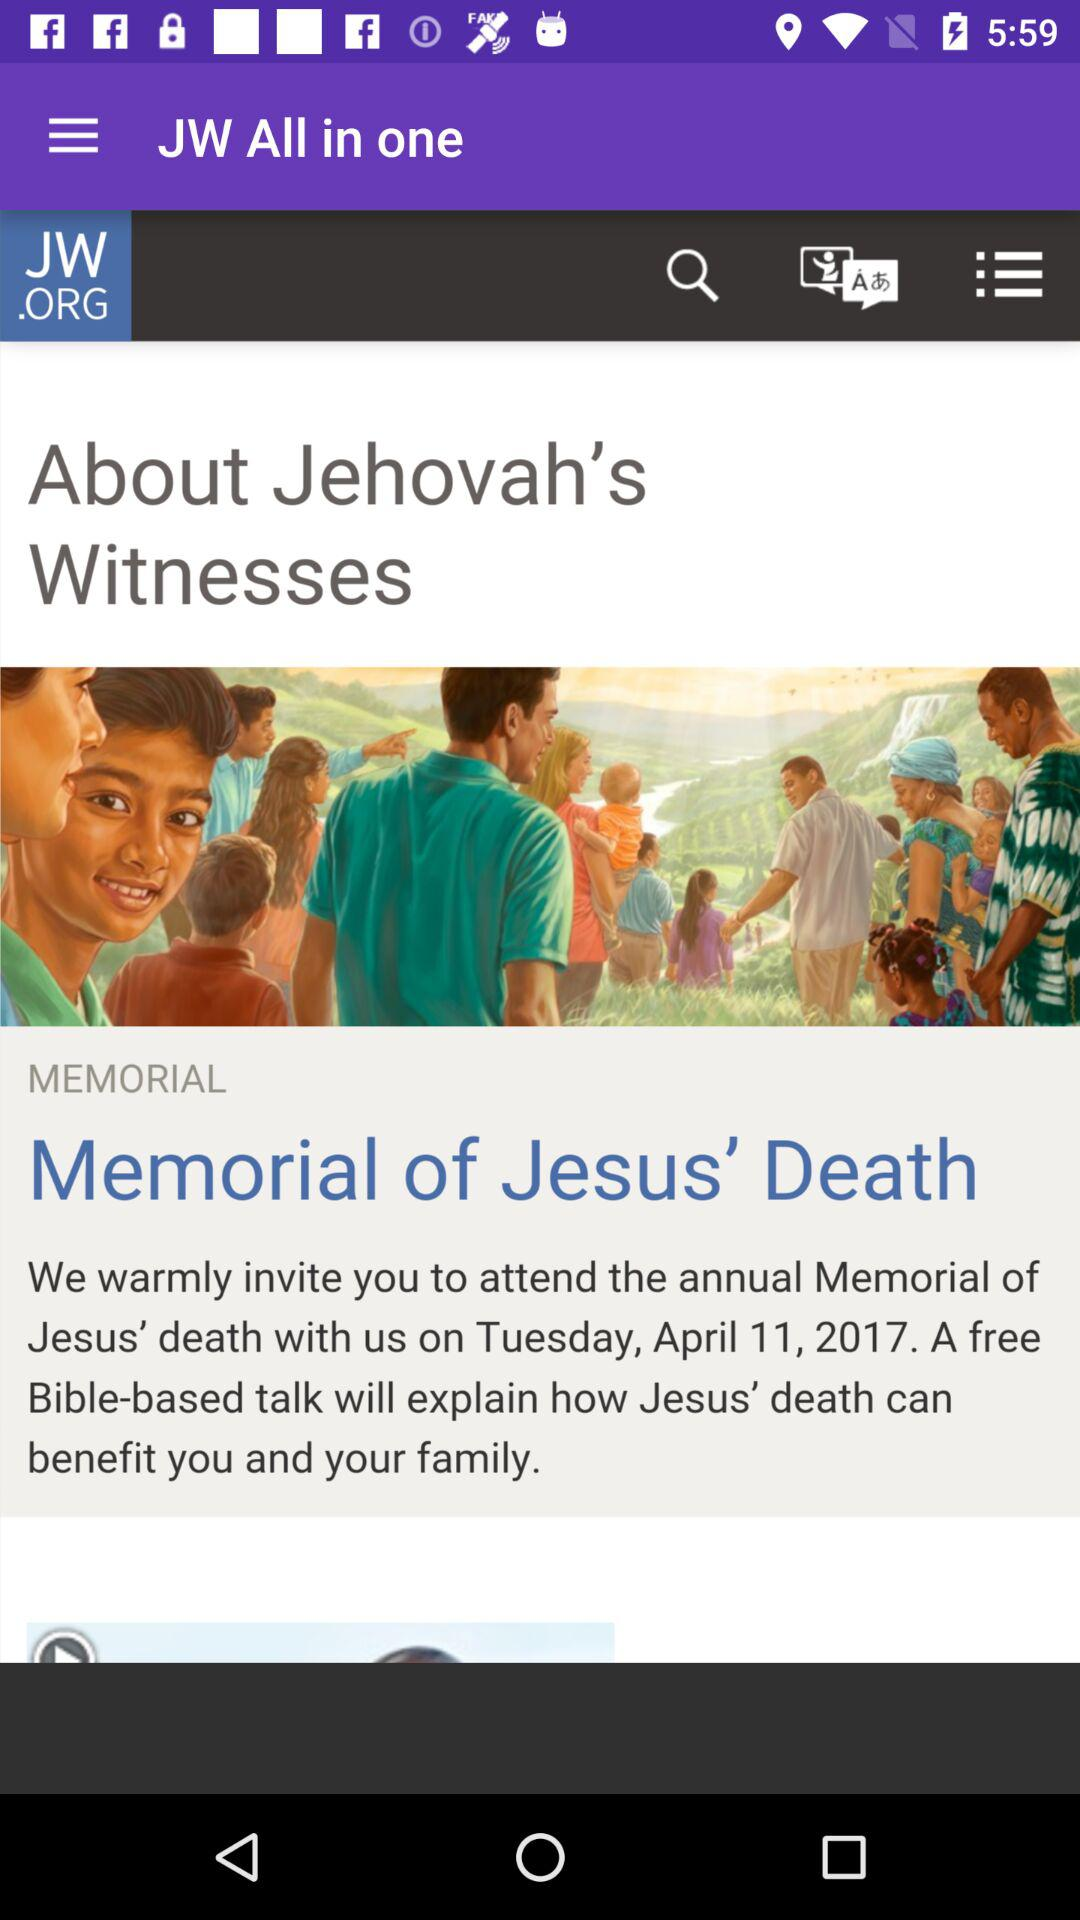What is the full form of JW? The full form of JW is Jehovah's Witnesses. 